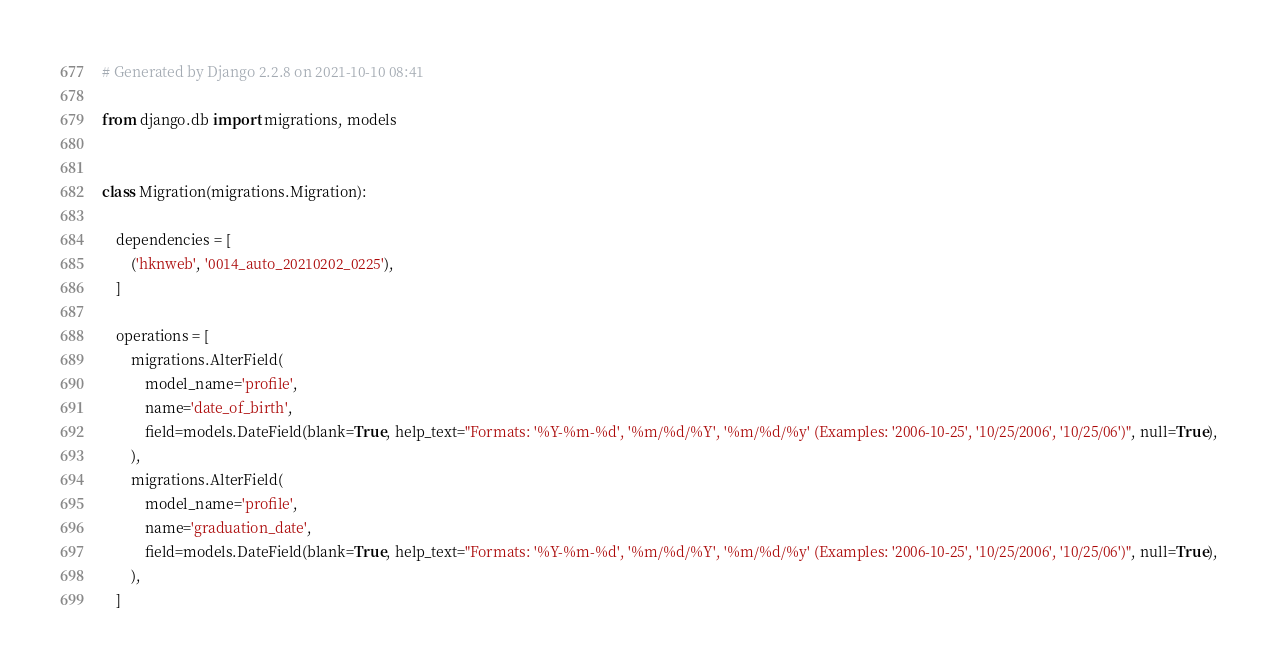Convert code to text. <code><loc_0><loc_0><loc_500><loc_500><_Python_># Generated by Django 2.2.8 on 2021-10-10 08:41

from django.db import migrations, models


class Migration(migrations.Migration):

    dependencies = [
        ('hknweb', '0014_auto_20210202_0225'),
    ]

    operations = [
        migrations.AlterField(
            model_name='profile',
            name='date_of_birth',
            field=models.DateField(blank=True, help_text="Formats: '%Y-%m-%d', '%m/%d/%Y', '%m/%d/%y' (Examples: '2006-10-25', '10/25/2006', '10/25/06')", null=True),
        ),
        migrations.AlterField(
            model_name='profile',
            name='graduation_date',
            field=models.DateField(blank=True, help_text="Formats: '%Y-%m-%d', '%m/%d/%Y', '%m/%d/%y' (Examples: '2006-10-25', '10/25/2006', '10/25/06')", null=True),
        ),
    ]
</code> 